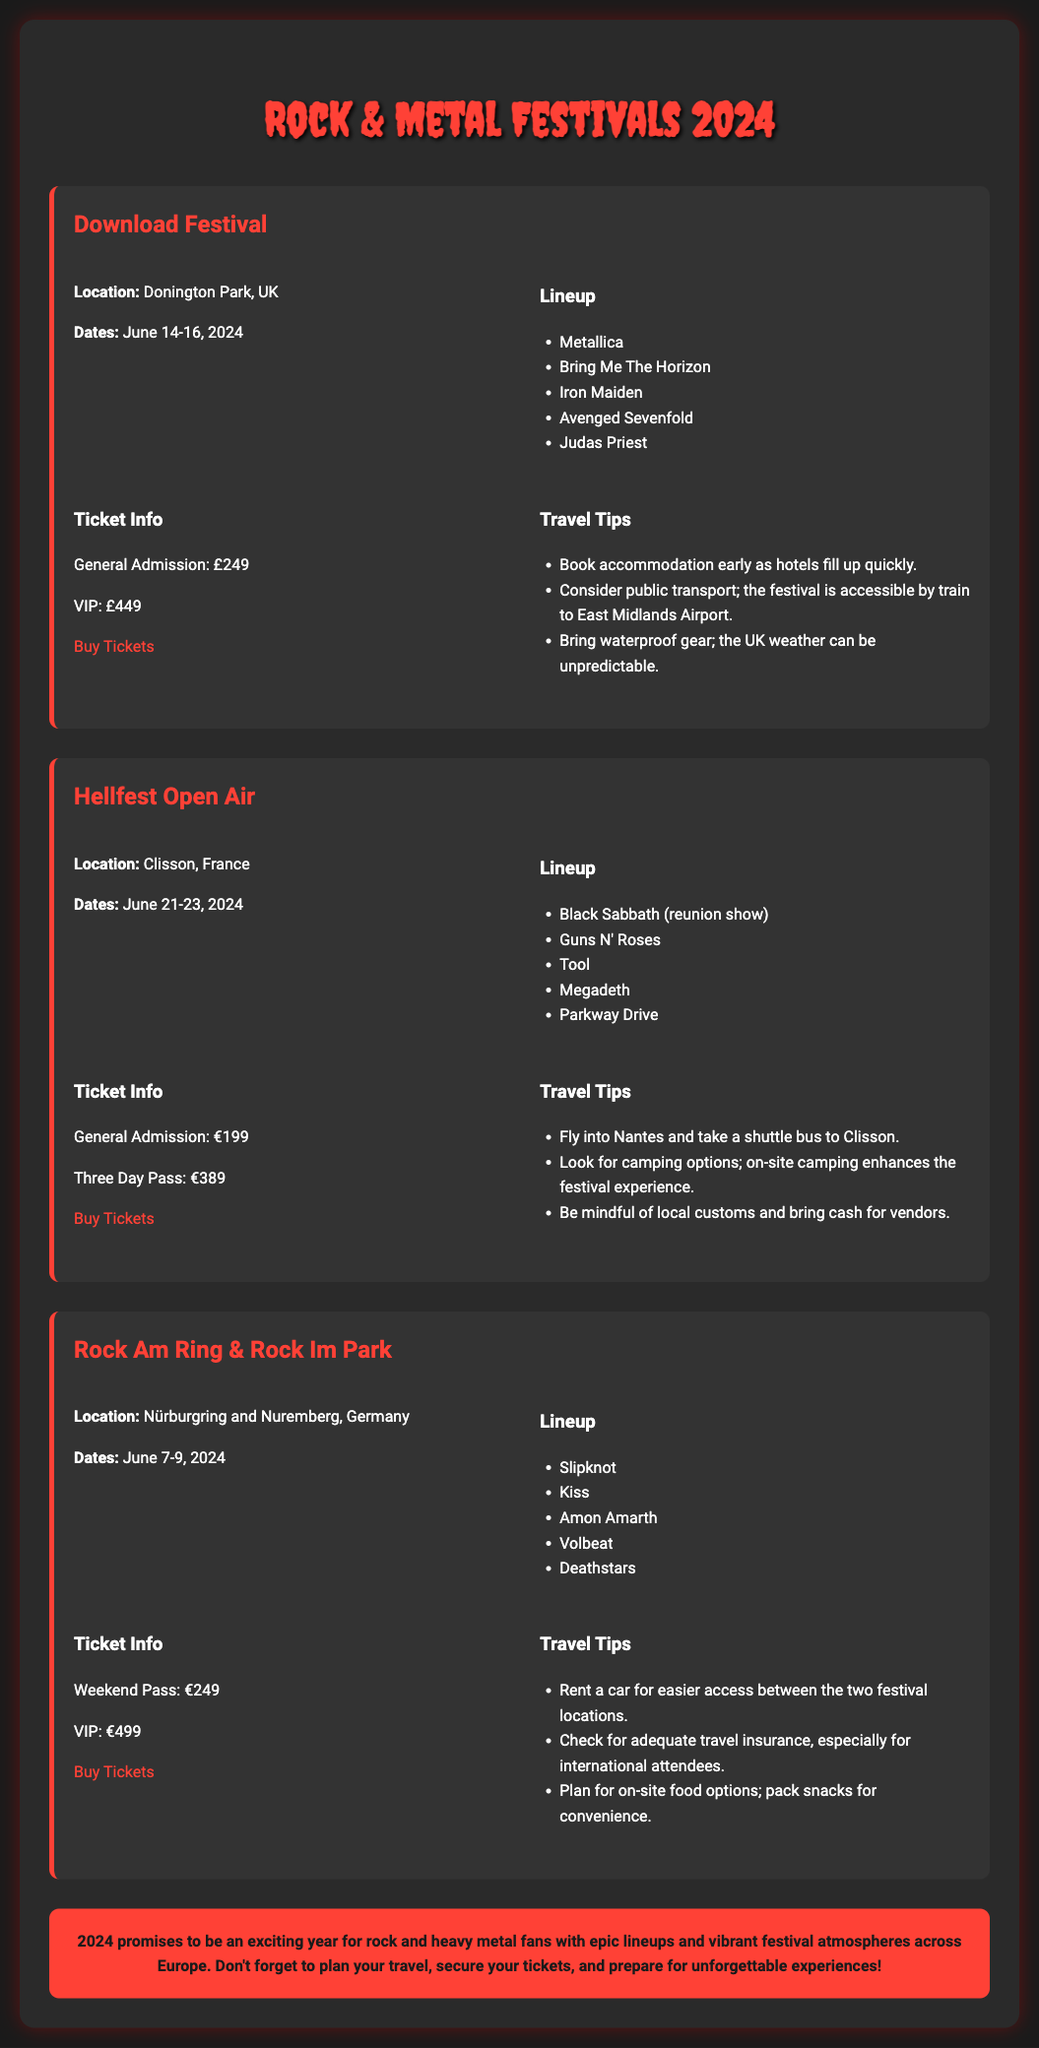What are the dates for the Download Festival? The Download Festival is scheduled for June 14-16, 2024, as stated in the document.
Answer: June 14-16, 2024 Who is performing at Hellfest Open Air? The lineup for Hellfest Open Air includes Black Sabbath, Guns N' Roses, Tool, Megadeth, and Parkway Drive, which is explicitly listed in the memo.
Answer: Black Sabbath, Guns N' Roses, Tool, Megadeth, Parkway Drive How much does a VIP ticket for the Download Festival cost? The document specifies that the VIP ticket for the Download Festival costs £449, detailing individual ticket prices under the ticket information section.
Answer: £449 What location hosts the Rock Am Ring & Rock Im Park festival? The festival is held at Nürburgring and Nuremberg, Germany, as mentioned in the festival details section.
Answer: Nürburgring and Nuremberg, Germany What unique travel tip is given for Hellfest Open Air? The memo suggests flying into Nantes and taking a shuttle bus to Clisson as a travel tip for attendees of Hellfest Open Air.
Answer: Fly into Nantes and take a shuttle bus to Clisson Which major band is featured in the Download Festival lineup? Metallica is listed as one of the major bands performing at the Download Festival, highlighting its significance in the lineup.
Answer: Metallica What is the total cost for a Three Day Pass at Hellfest Open Air? The memo states that a Three Day Pass costs €389, indicating the pricing structure for tickets at this festival.
Answer: €389 What should attendees of Rock Am Ring consider for food options? The travel tips suggest planning for on-site food options and packing snacks for convenience, emphasizing the need for food preparation.
Answer: Plan for on-site food options; pack snacks What is the primary focus of the conclusion section? The conclusion summarizes the excitement and planning necessary for rock and heavy metal fans in 2024, encapsulating the overall message of the document.
Answer: 2024 promises to be an exciting year for rock and heavy metal fans 